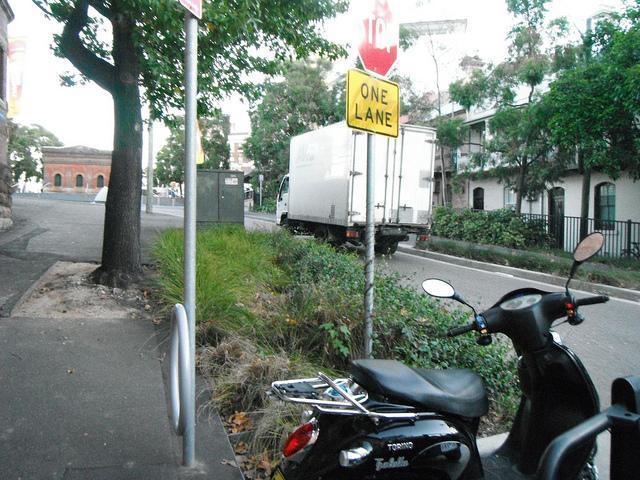How many trucks are in the picture?
Give a very brief answer. 2. 